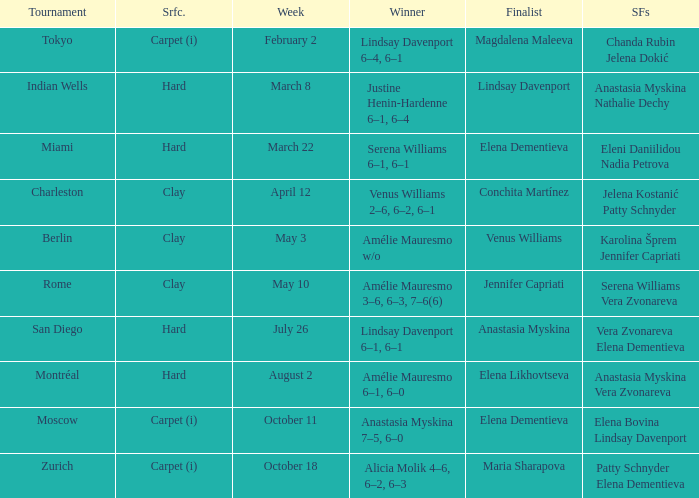Help me parse the entirety of this table. {'header': ['Tournament', 'Srfc.', 'Week', 'Winner', 'Finalist', 'SFs'], 'rows': [['Tokyo', 'Carpet (i)', 'February 2', 'Lindsay Davenport 6–4, 6–1', 'Magdalena Maleeva', 'Chanda Rubin Jelena Dokić'], ['Indian Wells', 'Hard', 'March 8', 'Justine Henin-Hardenne 6–1, 6–4', 'Lindsay Davenport', 'Anastasia Myskina Nathalie Dechy'], ['Miami', 'Hard', 'March 22', 'Serena Williams 6–1, 6–1', 'Elena Dementieva', 'Eleni Daniilidou Nadia Petrova'], ['Charleston', 'Clay', 'April 12', 'Venus Williams 2–6, 6–2, 6–1', 'Conchita Martínez', 'Jelena Kostanić Patty Schnyder'], ['Berlin', 'Clay', 'May 3', 'Amélie Mauresmo w/o', 'Venus Williams', 'Karolina Šprem Jennifer Capriati'], ['Rome', 'Clay', 'May 10', 'Amélie Mauresmo 3–6, 6–3, 7–6(6)', 'Jennifer Capriati', 'Serena Williams Vera Zvonareva'], ['San Diego', 'Hard', 'July 26', 'Lindsay Davenport 6–1, 6–1', 'Anastasia Myskina', 'Vera Zvonareva Elena Dementieva'], ['Montréal', 'Hard', 'August 2', 'Amélie Mauresmo 6–1, 6–0', 'Elena Likhovtseva', 'Anastasia Myskina Vera Zvonareva'], ['Moscow', 'Carpet (i)', 'October 11', 'Anastasia Myskina 7–5, 6–0', 'Elena Dementieva', 'Elena Bovina Lindsay Davenport'], ['Zurich', 'Carpet (i)', 'October 18', 'Alicia Molik 4–6, 6–2, 6–3', 'Maria Sharapova', 'Patty Schnyder Elena Dementieva']]} Who were the semifinalists in the Rome tournament? Serena Williams Vera Zvonareva. 